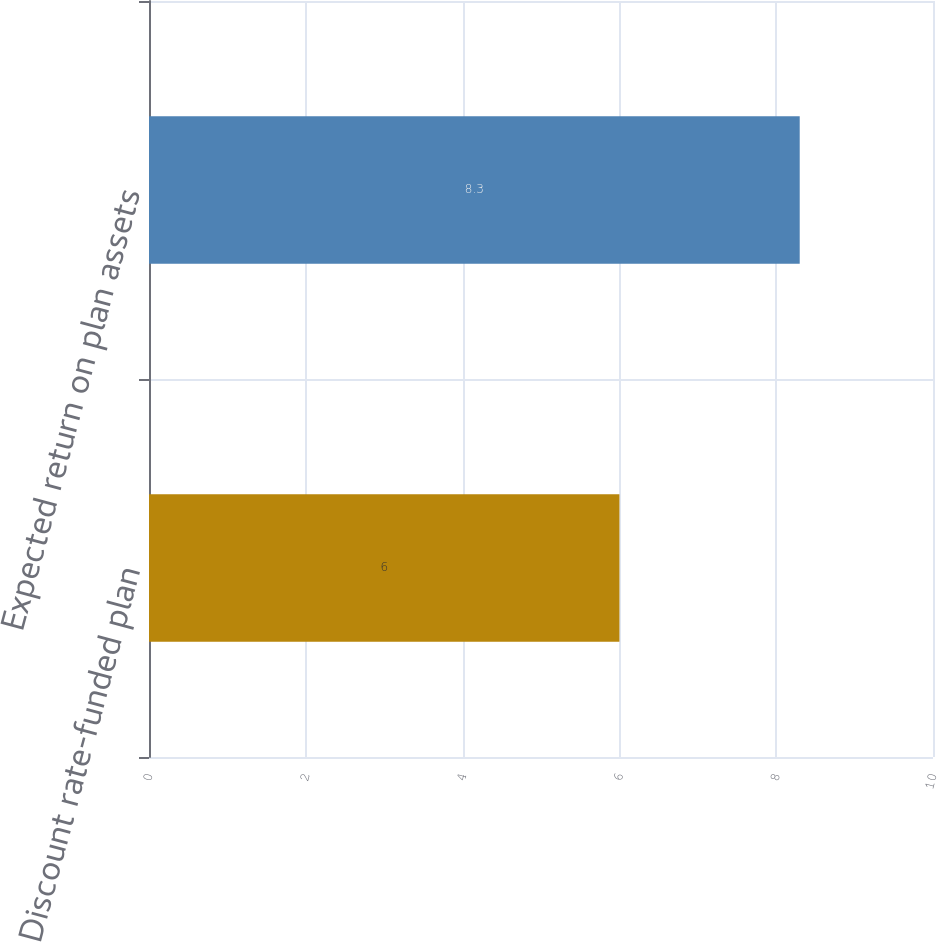Convert chart. <chart><loc_0><loc_0><loc_500><loc_500><bar_chart><fcel>Discount rate-funded plan<fcel>Expected return on plan assets<nl><fcel>6<fcel>8.3<nl></chart> 